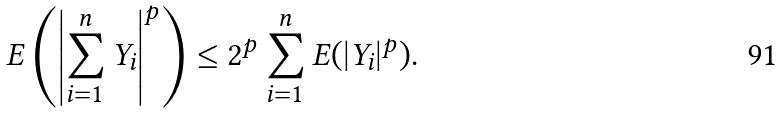Convert formula to latex. <formula><loc_0><loc_0><loc_500><loc_500>E \left ( \left | \sum _ { i = 1 } ^ { n } Y _ { i } \right | ^ { p } \right ) \leq 2 ^ { p } \sum _ { i = 1 } ^ { n } E ( | Y _ { i } | ^ { p } ) .</formula> 